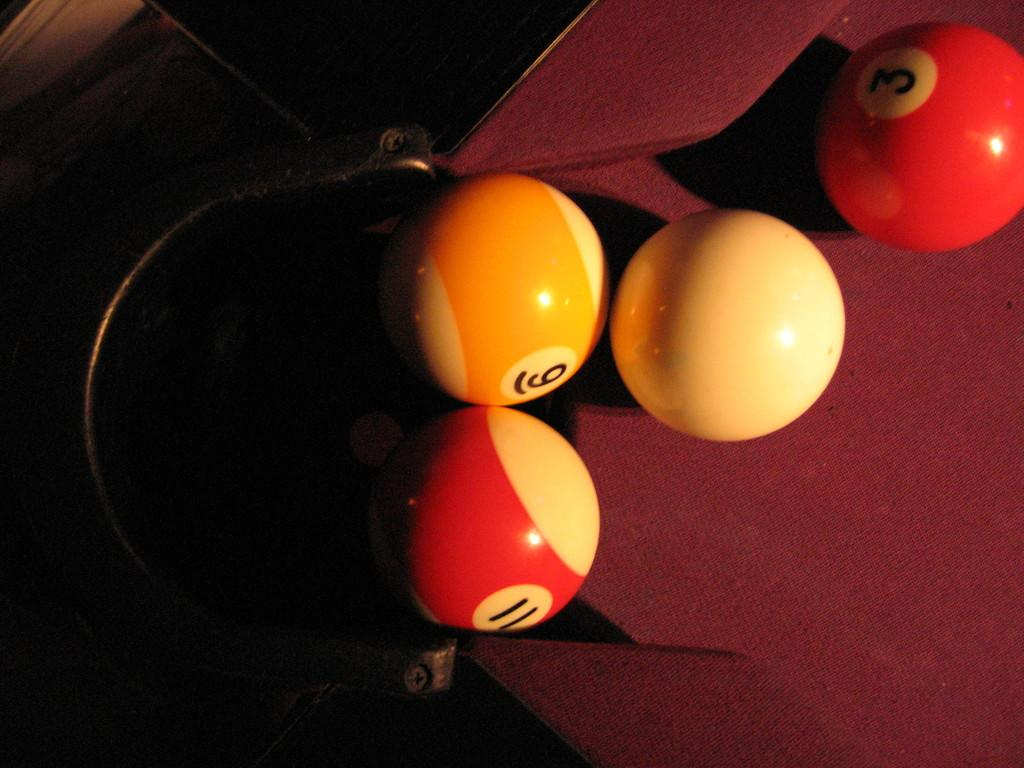<image>
Present a compact description of the photo's key features. Several pool balls sit on a table, including numer 9, 3, and 11. 